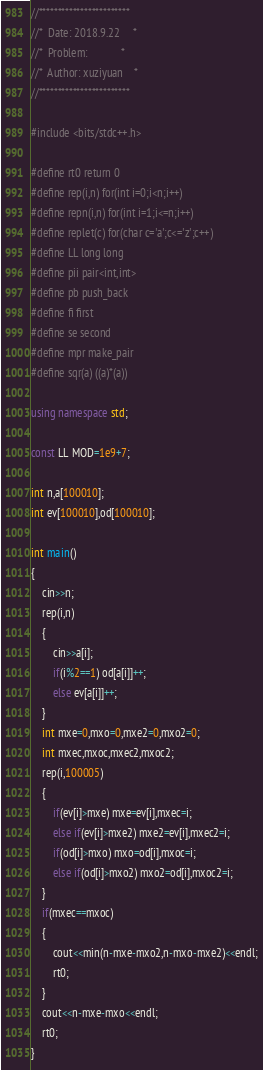<code> <loc_0><loc_0><loc_500><loc_500><_C++_>//************************
//*  Date: 2018.9.22     *
//*  Problem:            *
//*  Author: xuziyuan    * 
//************************
 
#include <bits/stdc++.h>
 
#define rt0 return 0
#define rep(i,n) for(int i=0;i<n;i++)
#define repn(i,n) for(int i=1;i<=n;i++)
#define replet(c) for(char c='a';c<='z';c++)
#define LL long long
#define pii pair<int,int>
#define pb push_back
#define fi first
#define se second
#define mpr make_pair
#define sqr(a) ((a)*(a))
 
using namespace std;
 
const LL MOD=1e9+7;
 
int n,a[100010];
int ev[100010],od[100010];
 
int main()
{
	cin>>n;
	rep(i,n)
	{
		cin>>a[i];
		if(i%2==1) od[a[i]]++;
		else ev[a[i]]++;
	}
	int mxe=0,mxo=0,mxe2=0,mxo2=0;
	int mxec,mxoc,mxec2,mxoc2;
	rep(i,100005)
	{
		if(ev[i]>mxe) mxe=ev[i],mxec=i;
		else if(ev[i]>mxe2) mxe2=ev[i],mxec2=i;
		if(od[i]>mxo) mxo=od[i],mxoc=i;
		else if(od[i]>mxo2) mxo2=od[i],mxoc2=i;
	}
	if(mxec==mxoc)
	{
		cout<<min(n-mxe-mxo2,n-mxo-mxe2)<<endl;
		rt0;
	}
	cout<<n-mxe-mxo<<endl;
	rt0;
}</code> 